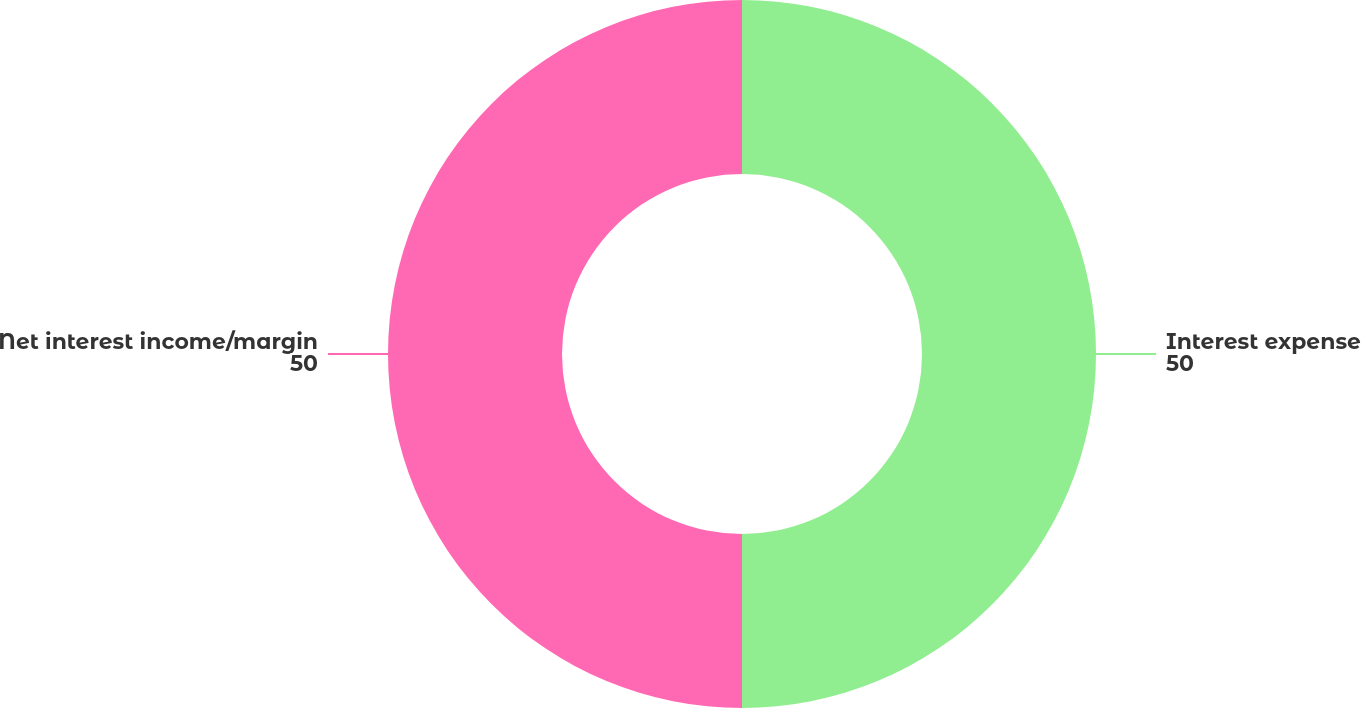<chart> <loc_0><loc_0><loc_500><loc_500><pie_chart><fcel>Interest expense<fcel>Net interest income/margin<nl><fcel>50.0%<fcel>50.0%<nl></chart> 